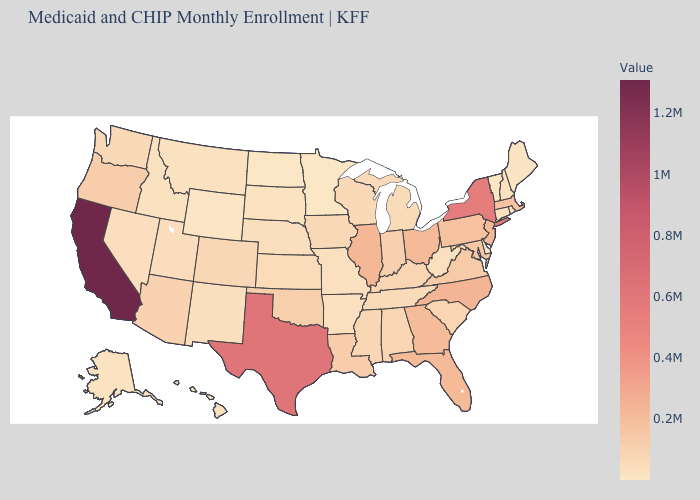Does Georgia have a higher value than Montana?
Short answer required. Yes. Is the legend a continuous bar?
Concise answer only. Yes. Does Washington have the highest value in the West?
Answer briefly. No. Is the legend a continuous bar?
Concise answer only. Yes. 